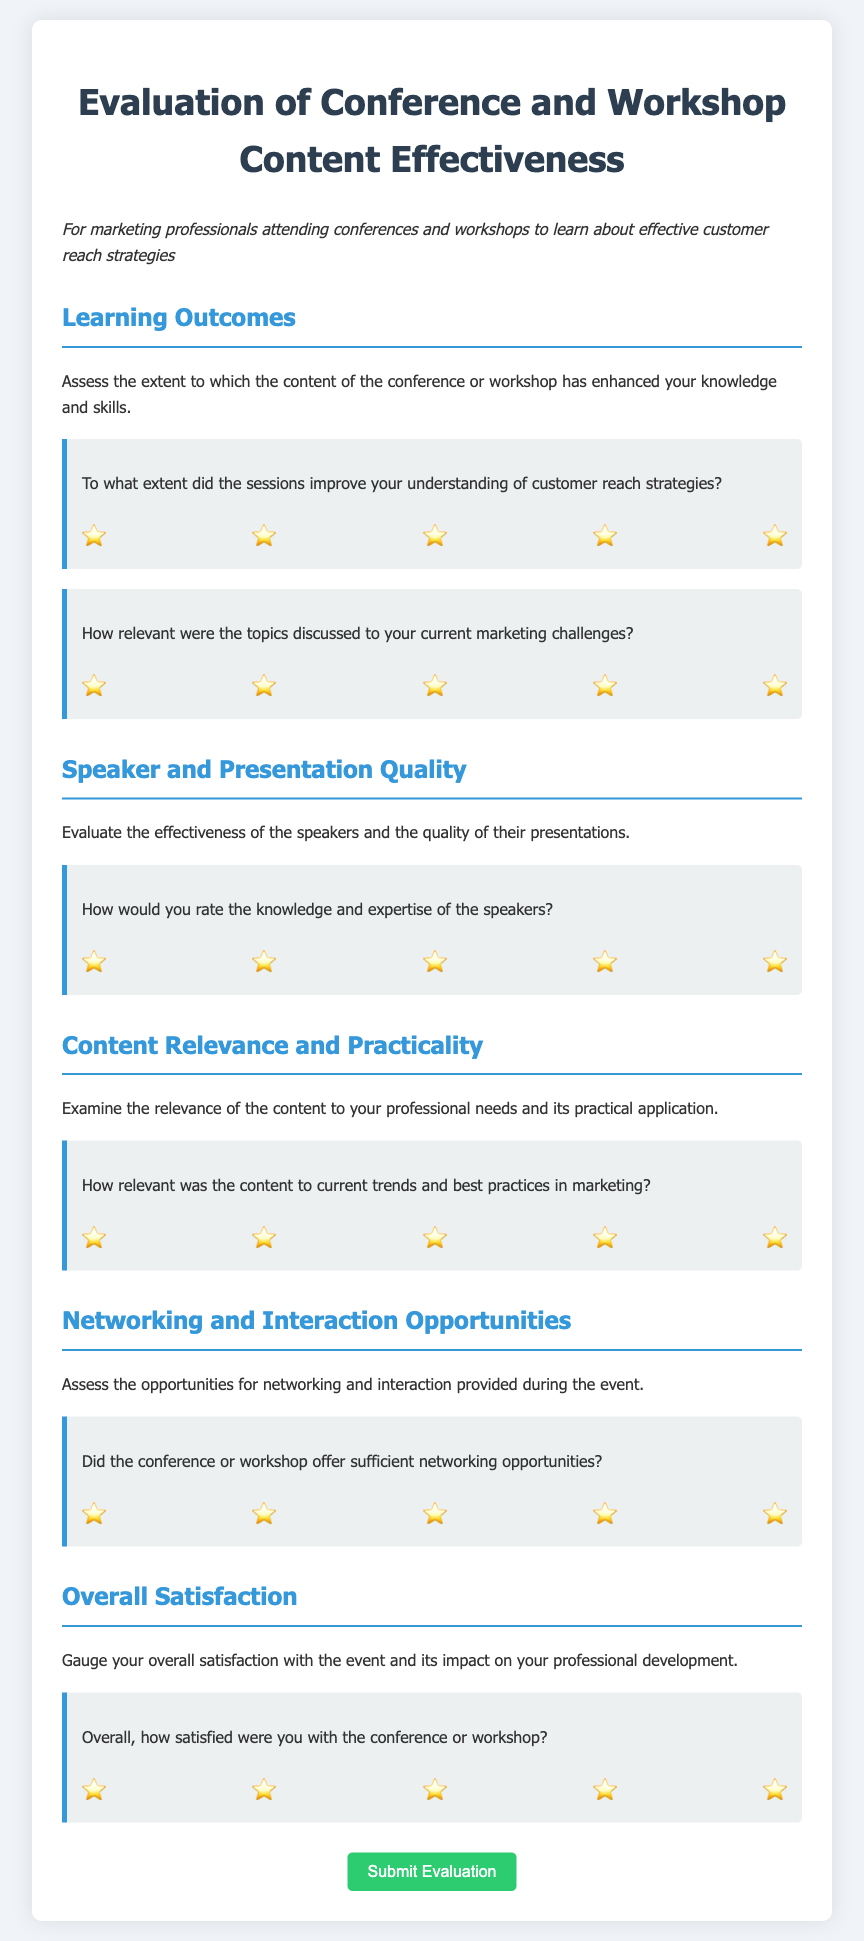What is the title of the document? The title of the document is found at the top of the page within the `<title>` tag and is presented prominently as the main heading.
Answer: Evaluation of Conference and Workshop Content Effectiveness What is the primary audience for this questionnaire? The primary audience is indicated at the beginning of the document in the introductory text, describing who the intended respondents are.
Answer: Marketing professionals How many main sections are there in the questionnaire? The number of main sections can be determined by counting the distinct headings within the form section of the document.
Answer: Five What question is asked regarding networking opportunities? The specific question about networking opportunities can be found in the "Networking and Interaction Opportunities" section of the document.
Answer: Did the conference or workshop offer sufficient networking opportunities? What rating scale is used for the questions? The rating scale is indicated through the options provided for each question, which consist of radio buttons.
Answer: 1 to 5 Which section assesses Speaker and Presentation Quality? The section that evaluates the effectiveness of speakers is clearly labeled within the document.
Answer: Speaker and Presentation Quality How many questions are there in the Learning Outcomes section? The number of questions can be counted within the "Learning Outcomes" heading and related content.
Answer: Two What is the submit button label? The label for the submit button is found as part of the form at the bottom of the document.
Answer: Submit Evaluation 